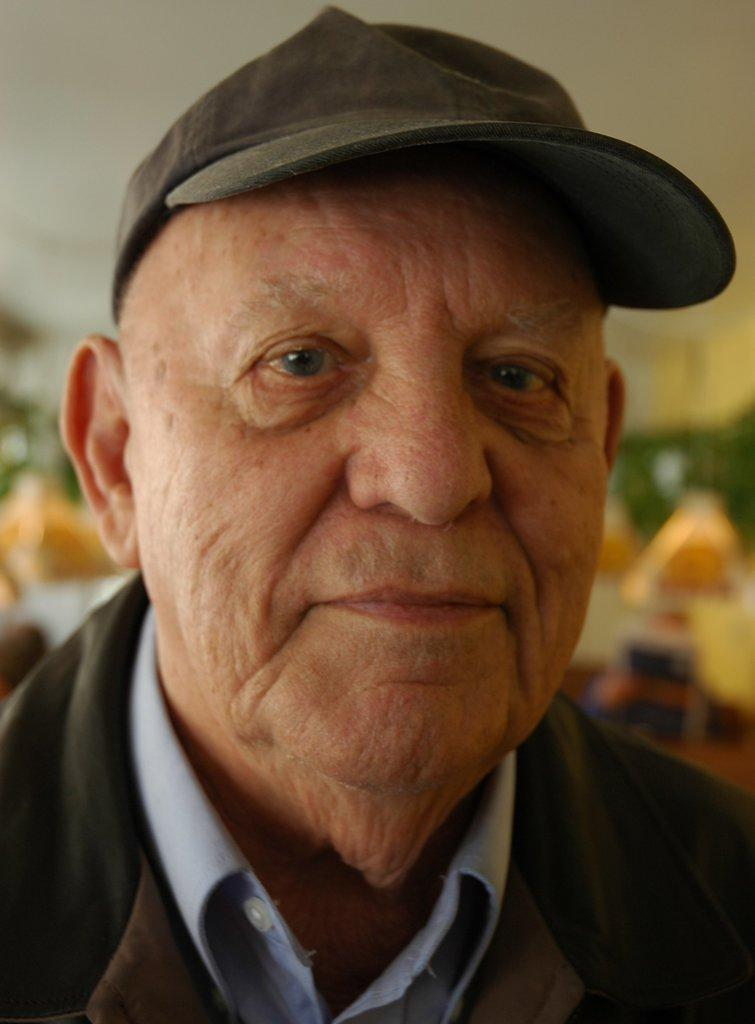Who is the main subject in the image? There is an old man in the image. What is the old man wearing on his head? The old man is wearing a cap. What type of bone can be seen sticking out of the old man's cap in the image? There is no bone visible in the image, nor is there any indication that the old man's cap has a bone attached to it. 